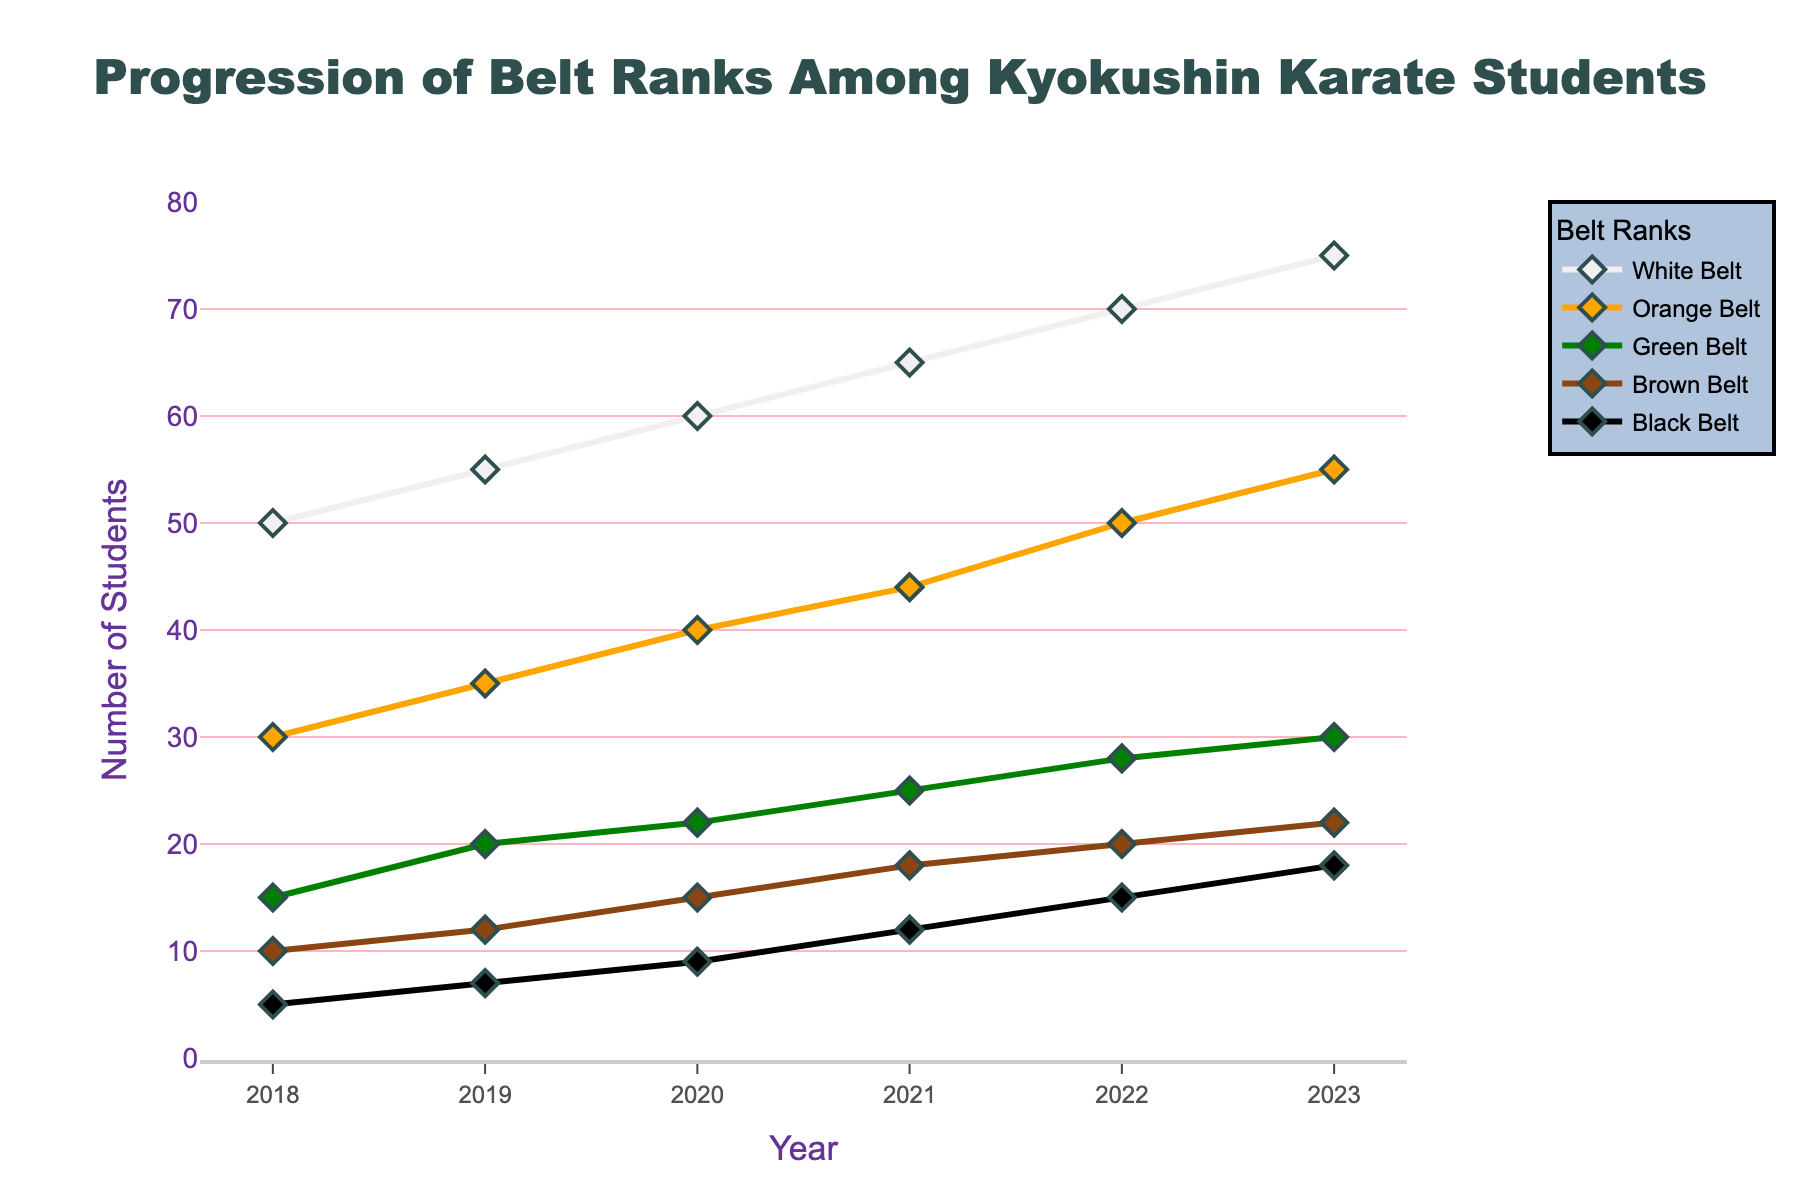What's the title of the plot? The title is displayed prominently at the top of the plot
Answer: Progression of Belt Ranks Among Kyokushin Karate Students Which belt rank has the highest number of students in 2023? Look at the data point for 2023 and observe the values for each belt rank
Answer: White Belt How many students were Brown Belts in 2020? Locate the year 2020 on the x-axis, then check the corresponding value for the Brown Belt line
Answer: 15 What is the general trend observed for the number of students achieving Black Belt over the years? Check the plotted line for Black Belt from 2018 to 2023 and observe whether it increases, decreases, or remains constant
Answer: Increasing What’s the difference in the number of Green Belt students between 2018 and 2021? Subtract the number of Green Belt students in 2018 from those in 2021 (25 - 15)
Answer: 10 Which year saw the highest growth in Orange Belt students compared to the previous year? Calculate the year-over-year increase for Orange Belt students and identify the year with the highest increment
Answer: 2019 How many students in total were there in 2022 across all belt ranks? Add the number of students from all belt ranks for the year 2022 (70 + 50 + 28 + 20 + 15)
Answer: 183 Between which consecutive years did the number of Black Belt students increase the most? Calculate the year-over-year increase for Black Belt students and identify the two consecutive years with the largest increase
Answer: 2020 to 2021 Compare the number of White Belt and Orange Belt students in 2018. Which was higher and by how much? Subtract the number of Orange Belt students from the number of White Belt students in 2018 (50 - 30)
Answer: White Belt by 20 What is the average number of Green Belt students from 2018 to 2023? Sum the Green Belt students over the years and divide by the number of years (15 + 20 + 22 + 25 + 28 + 30) / 6
Answer: 23.33 